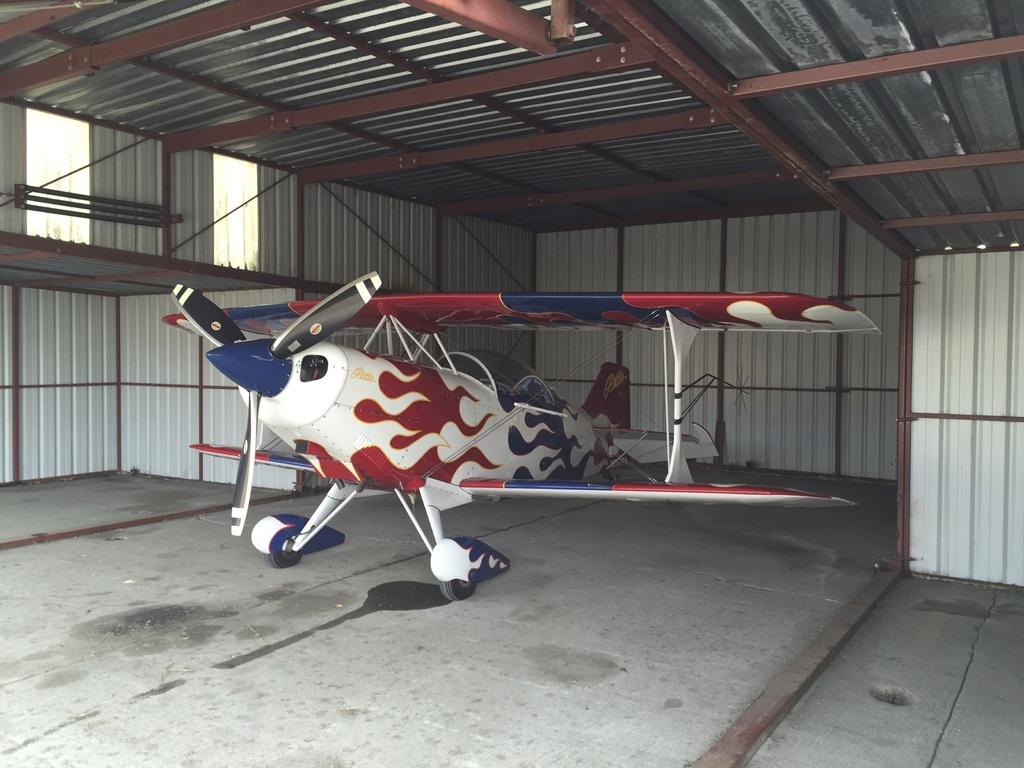What is the main subject of the image? The main subject of the image is an aircraft. Where is the aircraft located in the image? The aircraft is inside a metal shed. What are the walls of the metal shed made of? The walls of the metal shed are made of metal. What is the roof of the metal shed made of? The roof of the metal shed is made of metal. How is the metal roof supported? The metal roof is supported by metal rods. What is your opinion about the paste used in the construction of the metal shed? There is no mention of paste in the provided facts, and the question is not related to the image. 